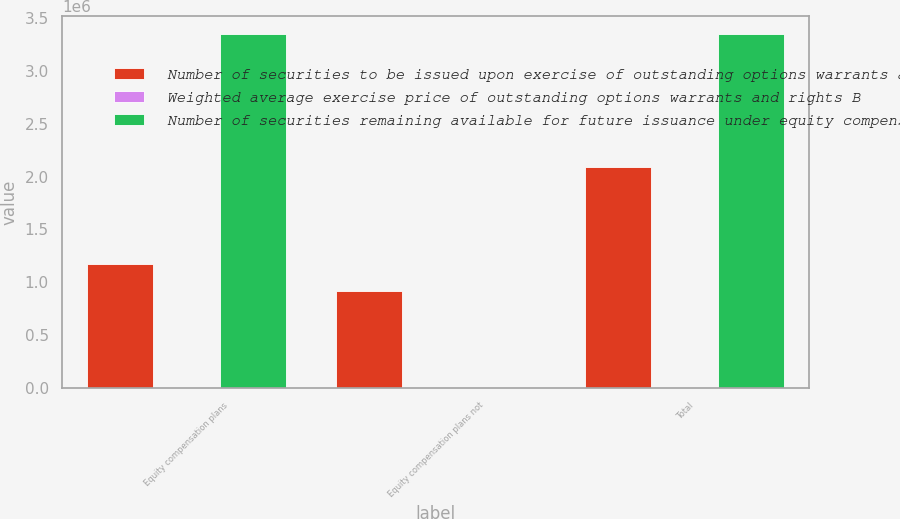Convert chart. <chart><loc_0><loc_0><loc_500><loc_500><stacked_bar_chart><ecel><fcel>Equity compensation plans<fcel>Equity compensation plans not<fcel>Total<nl><fcel>Number of securities to be issued upon exercise of outstanding options warrants and rights A<fcel>1.17568e+06<fcel>915540<fcel>2.09122e+06<nl><fcel>Weighted average exercise price of outstanding options warrants and rights B<fcel>25.09<fcel>24.43<fcel>24.8<nl><fcel>Number of securities remaining available for future issuance under equity compensation plans excluding securities reflected in column A C<fcel>3.35403e+06<fcel>0<fcel>3.35403e+06<nl></chart> 